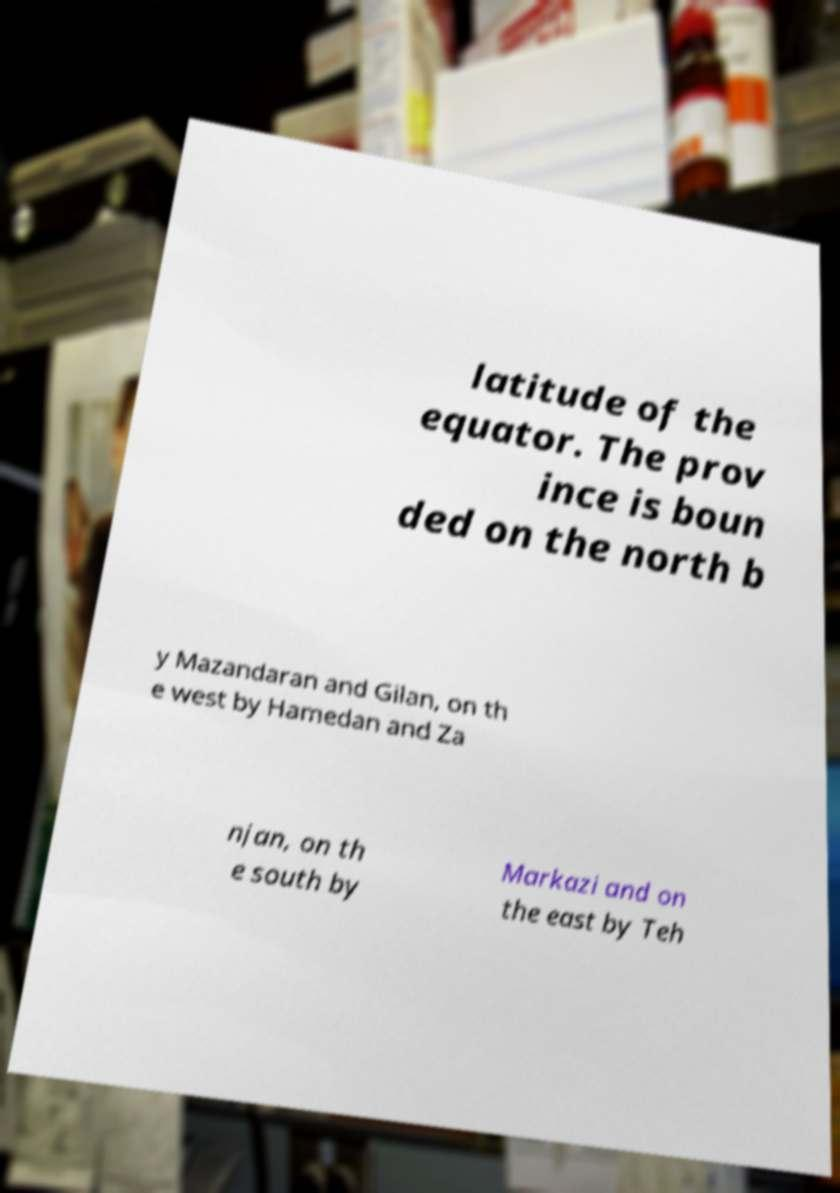Could you extract and type out the text from this image? latitude of the equator. The prov ince is boun ded on the north b y Mazandaran and Gilan, on th e west by Hamedan and Za njan, on th e south by Markazi and on the east by Teh 